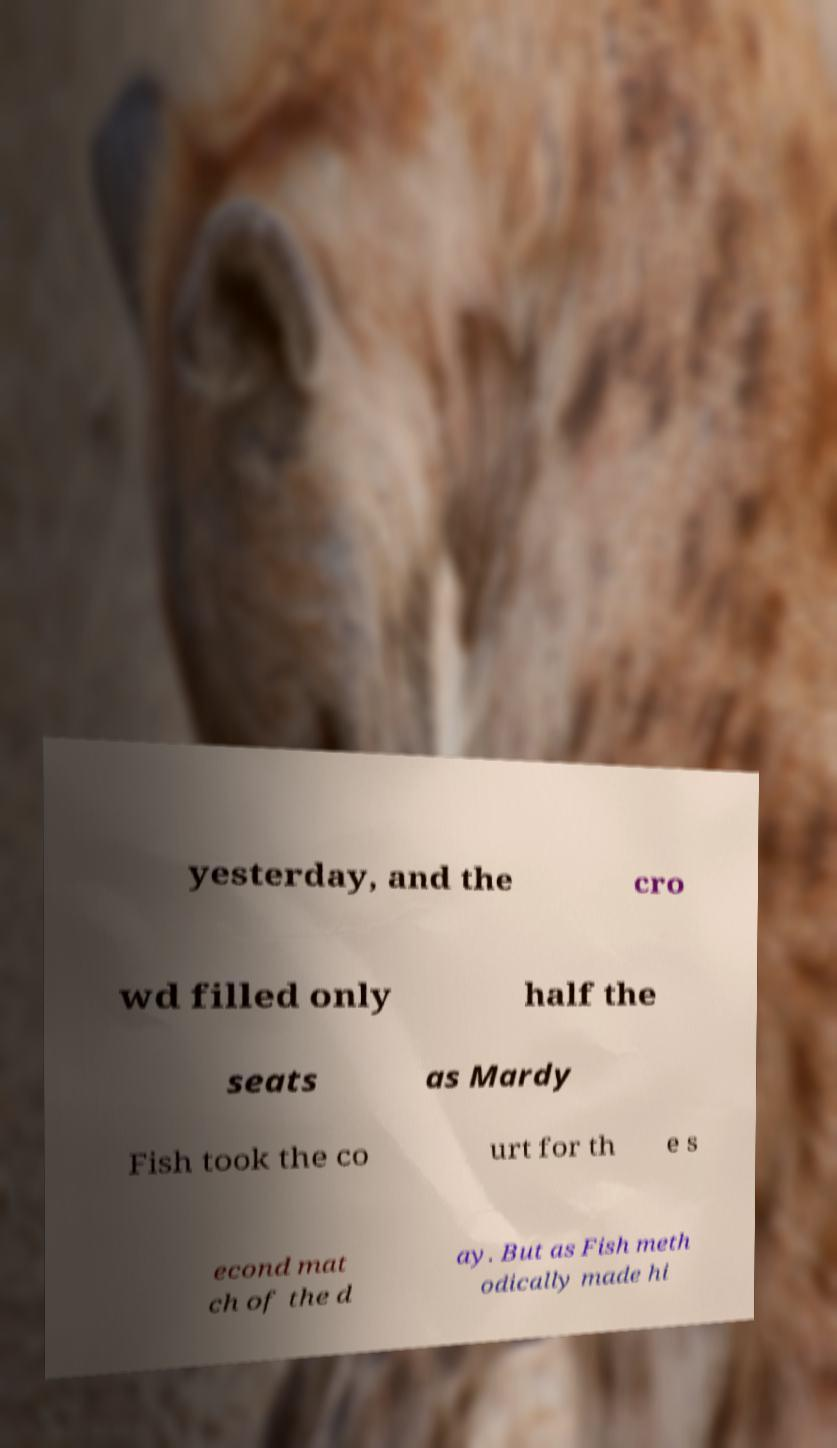There's text embedded in this image that I need extracted. Can you transcribe it verbatim? yesterday, and the cro wd filled only half the seats as Mardy Fish took the co urt for th e s econd mat ch of the d ay. But as Fish meth odically made hi 